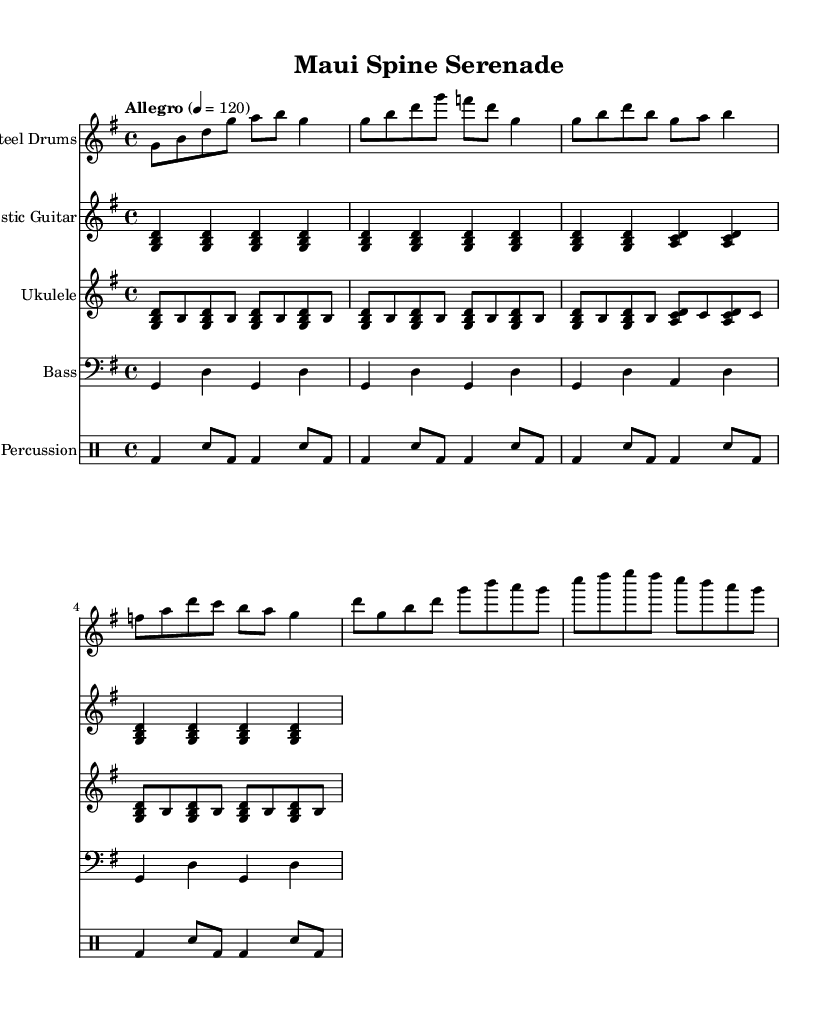What is the key signature of this music? The key signature is G major, indicated by one sharp (F#) in the left-hand corner of the sheet music.
Answer: G major What is the time signature of this piece? The time signature is 4/4, which is shown at the beginning of the sheet music. This means there are four beats per measure.
Answer: 4/4 What is the tempo marking for this piece? The tempo marking is "Allegro," which indicates a fast and cheerful speed of the music, specifically noted with a metronome marking of 120 beats per minute.
Answer: Allegro How many measures does the first section contain? The first section, represented by the staff for steel drums, contains four measures. Each measure corresponds to the vertical bar lines on the staff.
Answer: Four Which instrument has the highest pitch? The ukulele has the highest pitch, as indicated by the notation and the range of notes used compared to other instruments in this arrangement.
Answer: Ukulele What type of music is represented by this piece? This piece represents upbeat tropical fusion music, combining elements typical of islands and beach atmospheres, suitable for a chiropractic clinic environment.
Answer: Tropical fusion 